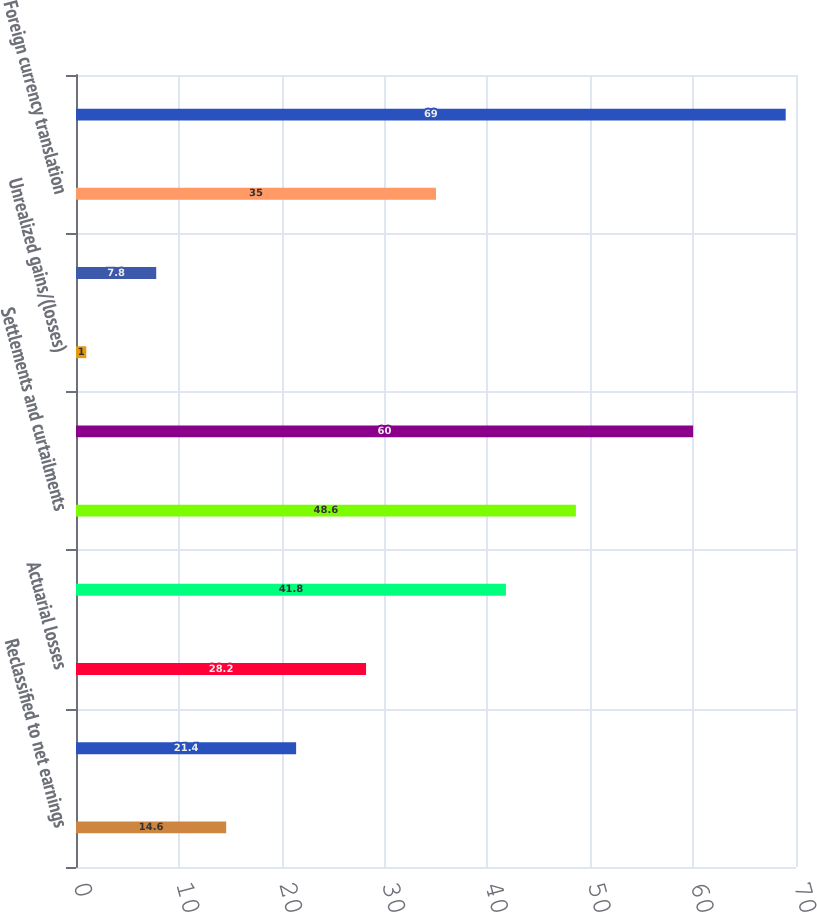Convert chart. <chart><loc_0><loc_0><loc_500><loc_500><bar_chart><fcel>Reclassified to net earnings<fcel>Derivatives qualifying as cash<fcel>Actuarial losses<fcel>Amortization (b)<fcel>Settlements and curtailments<fcel>Pension and other<fcel>Unrealized gains/(losses)<fcel>Available-for-sale securities<fcel>Foreign currency translation<fcel>Total Other Comprehensive<nl><fcel>14.6<fcel>21.4<fcel>28.2<fcel>41.8<fcel>48.6<fcel>60<fcel>1<fcel>7.8<fcel>35<fcel>69<nl></chart> 